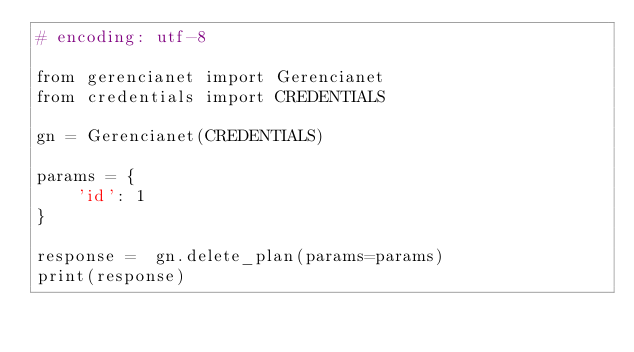<code> <loc_0><loc_0><loc_500><loc_500><_Python_># encoding: utf-8

from gerencianet import Gerencianet
from credentials import CREDENTIALS

gn = Gerencianet(CREDENTIALS)

params = {
    'id': 1
}

response =  gn.delete_plan(params=params)
print(response)
</code> 